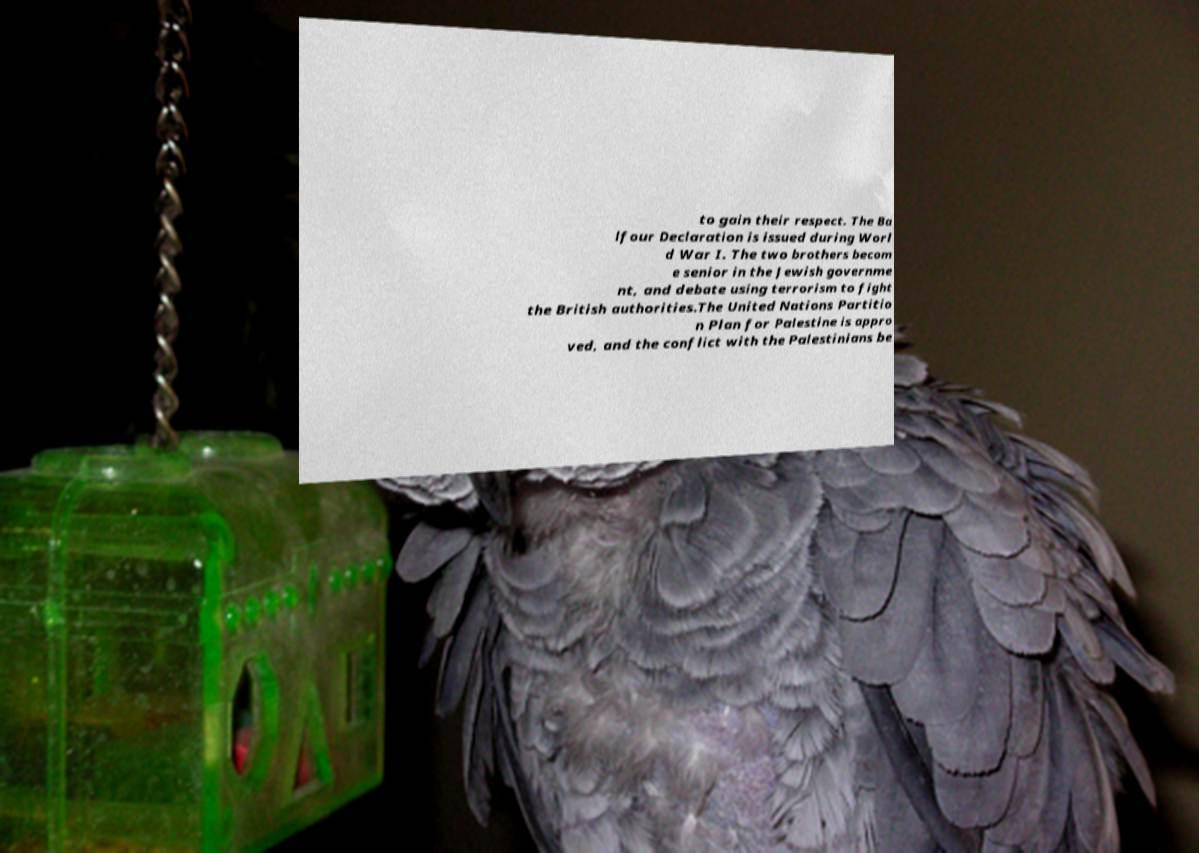There's text embedded in this image that I need extracted. Can you transcribe it verbatim? to gain their respect. The Ba lfour Declaration is issued during Worl d War I. The two brothers becom e senior in the Jewish governme nt, and debate using terrorism to fight the British authorities.The United Nations Partitio n Plan for Palestine is appro ved, and the conflict with the Palestinians be 